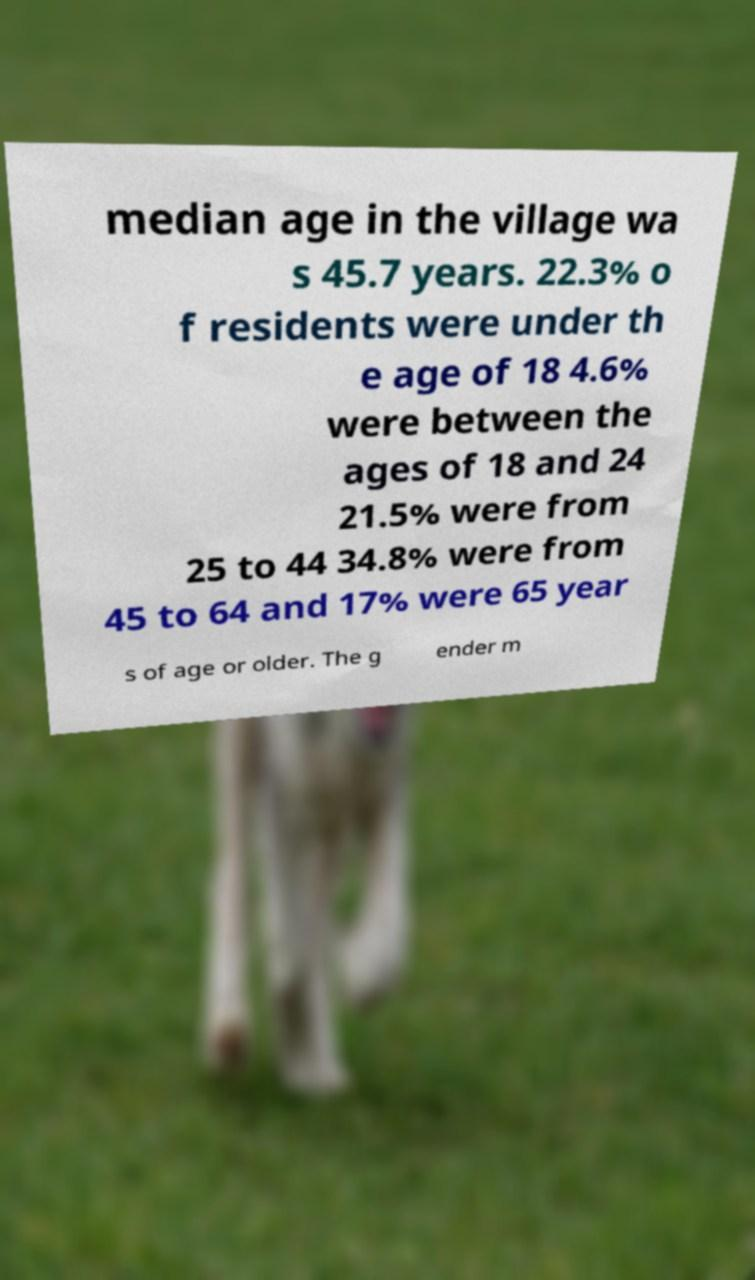I need the written content from this picture converted into text. Can you do that? median age in the village wa s 45.7 years. 22.3% o f residents were under th e age of 18 4.6% were between the ages of 18 and 24 21.5% were from 25 to 44 34.8% were from 45 to 64 and 17% were 65 year s of age or older. The g ender m 